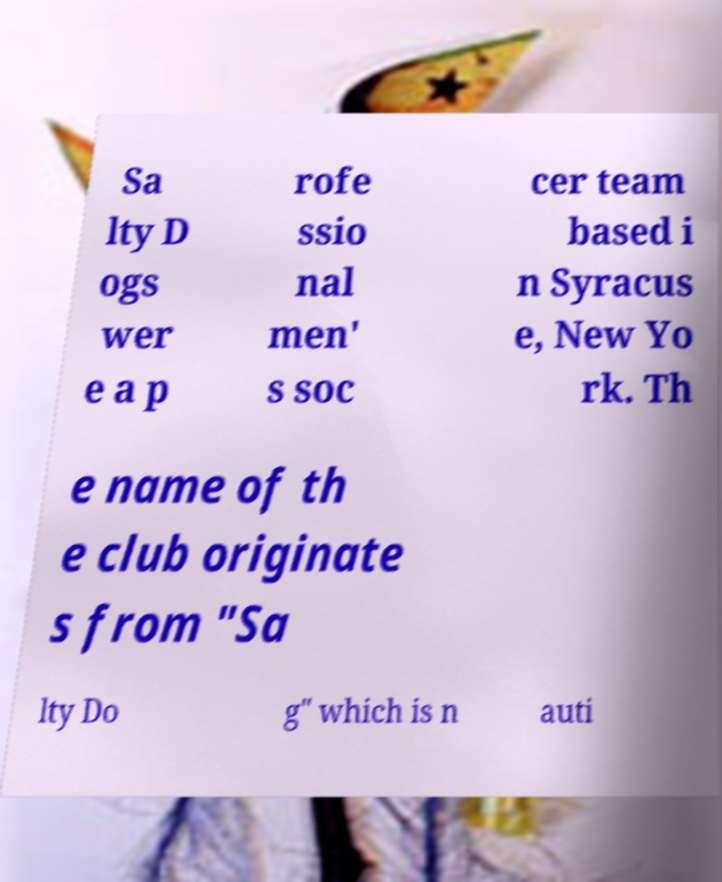Could you assist in decoding the text presented in this image and type it out clearly? Sa lty D ogs wer e a p rofe ssio nal men' s soc cer team based i n Syracus e, New Yo rk. Th e name of th e club originate s from "Sa lty Do g" which is n auti 